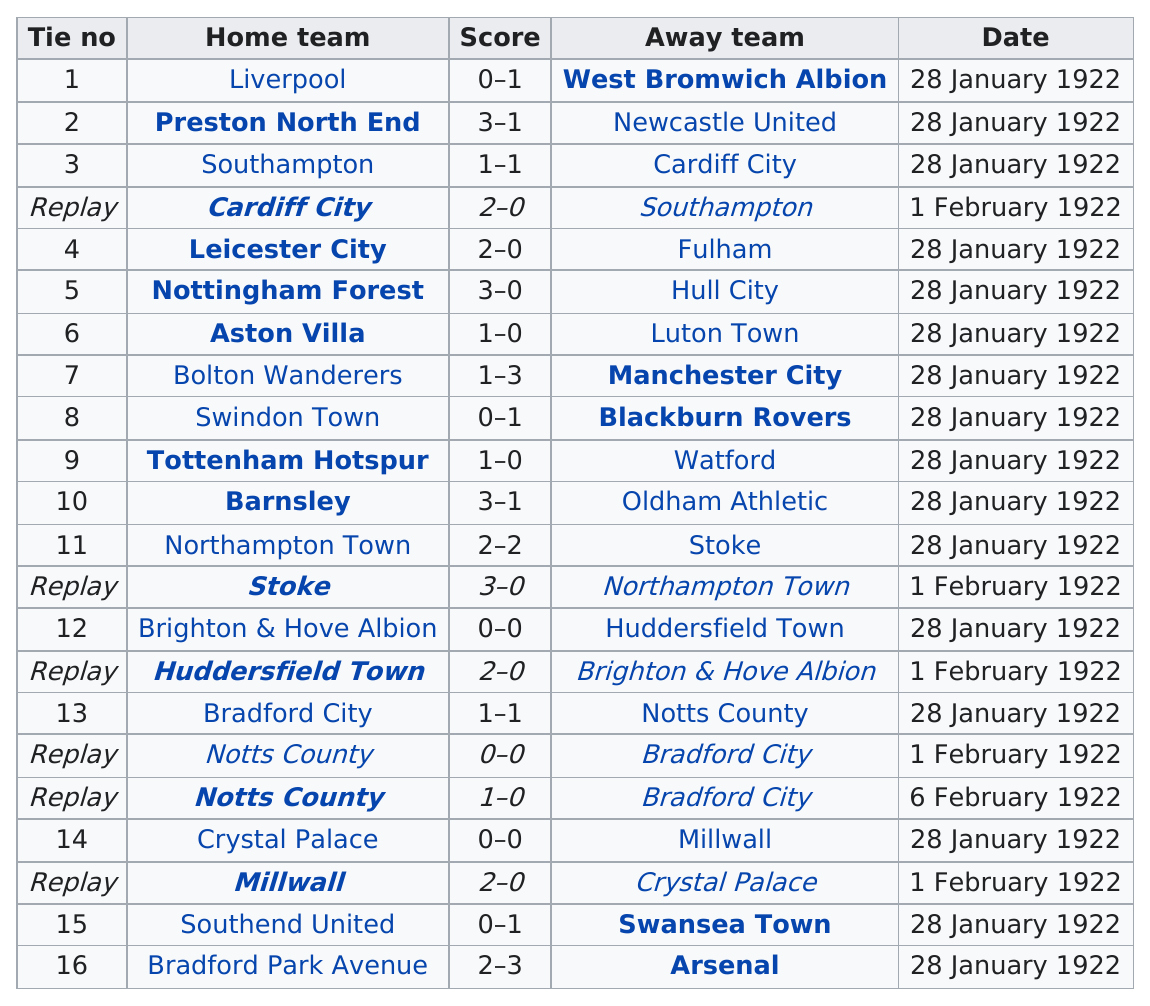Specify some key components in this picture. Out of the total number of games played, three games did not feature any points scored. The home team that had the same score as Aston Villa on January 28th, 1922, was Tottenham Hotspur. On February 6th, 1922, the number of points scored is unknown. The game with a higher total number of goals scored was 16. In the second round proper, a total of 45 points were scored. 